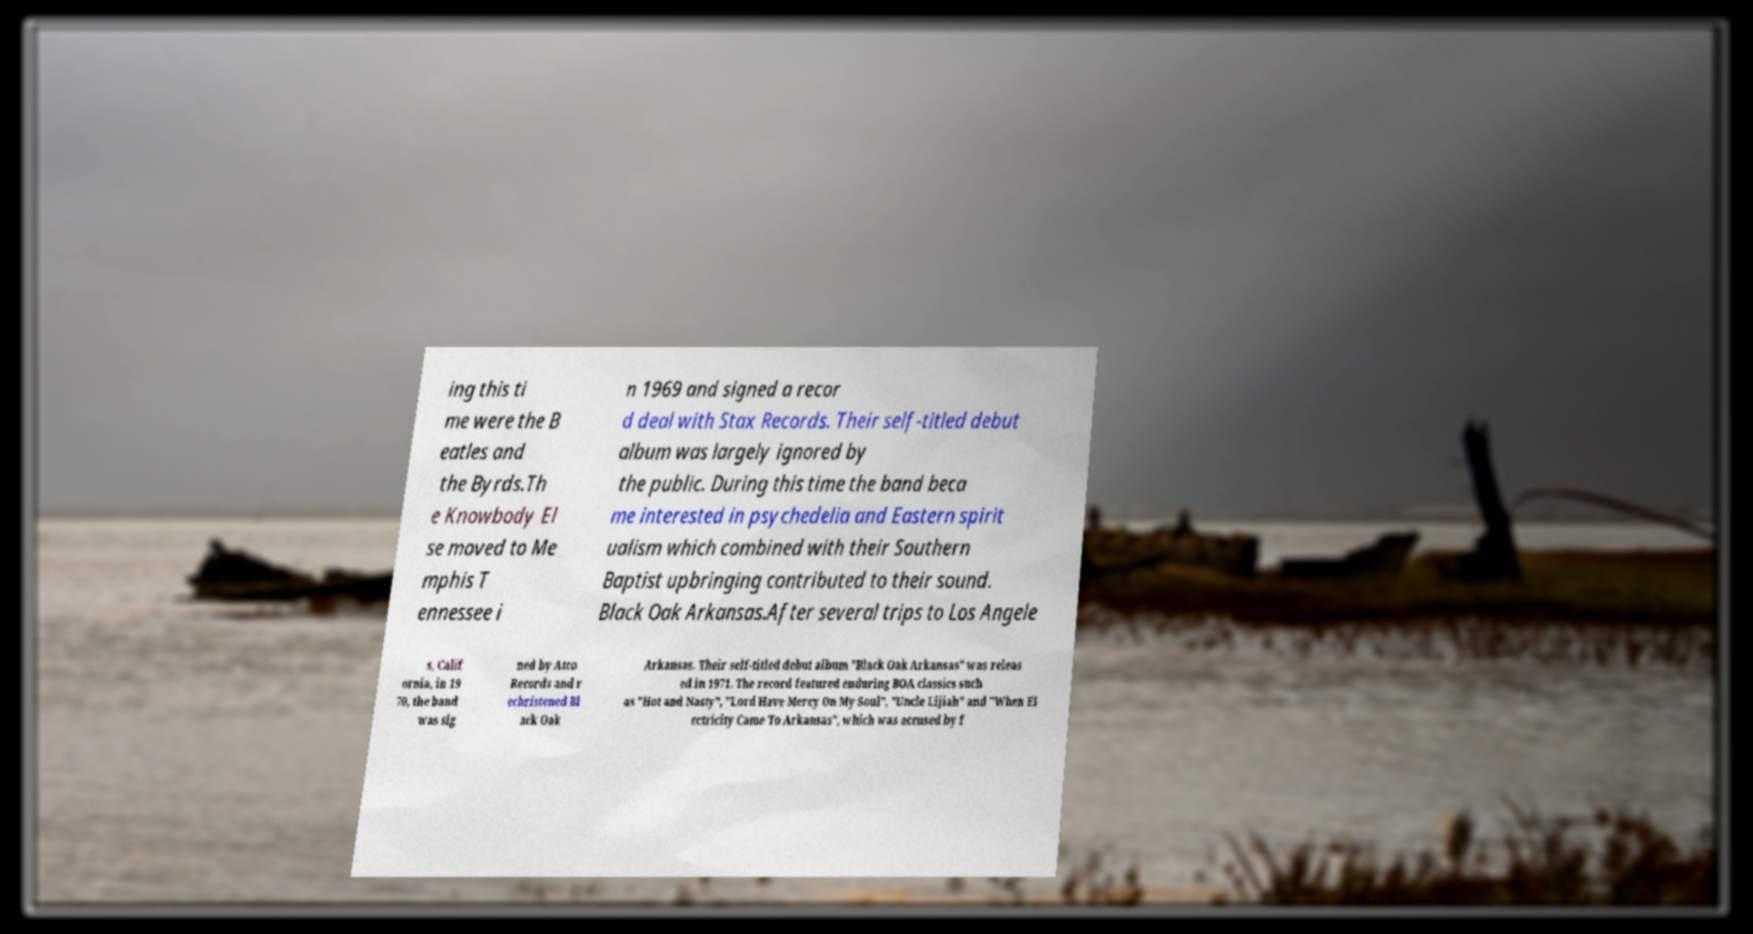Please read and relay the text visible in this image. What does it say? ing this ti me were the B eatles and the Byrds.Th e Knowbody El se moved to Me mphis T ennessee i n 1969 and signed a recor d deal with Stax Records. Their self-titled debut album was largely ignored by the public. During this time the band beca me interested in psychedelia and Eastern spirit ualism which combined with their Southern Baptist upbringing contributed to their sound. Black Oak Arkansas.After several trips to Los Angele s, Calif ornia, in 19 70, the band was sig ned by Atco Records and r echristened Bl ack Oak Arkansas. Their self-titled debut album "Black Oak Arkansas" was releas ed in 1971. The record featured enduring BOA classics such as "Hot and Nasty", "Lord Have Mercy On My Soul", "Uncle Lijiah" and "When El ectricity Came To Arkansas", which was accused by f 